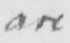Transcribe the text shown in this historical manuscript line. are 